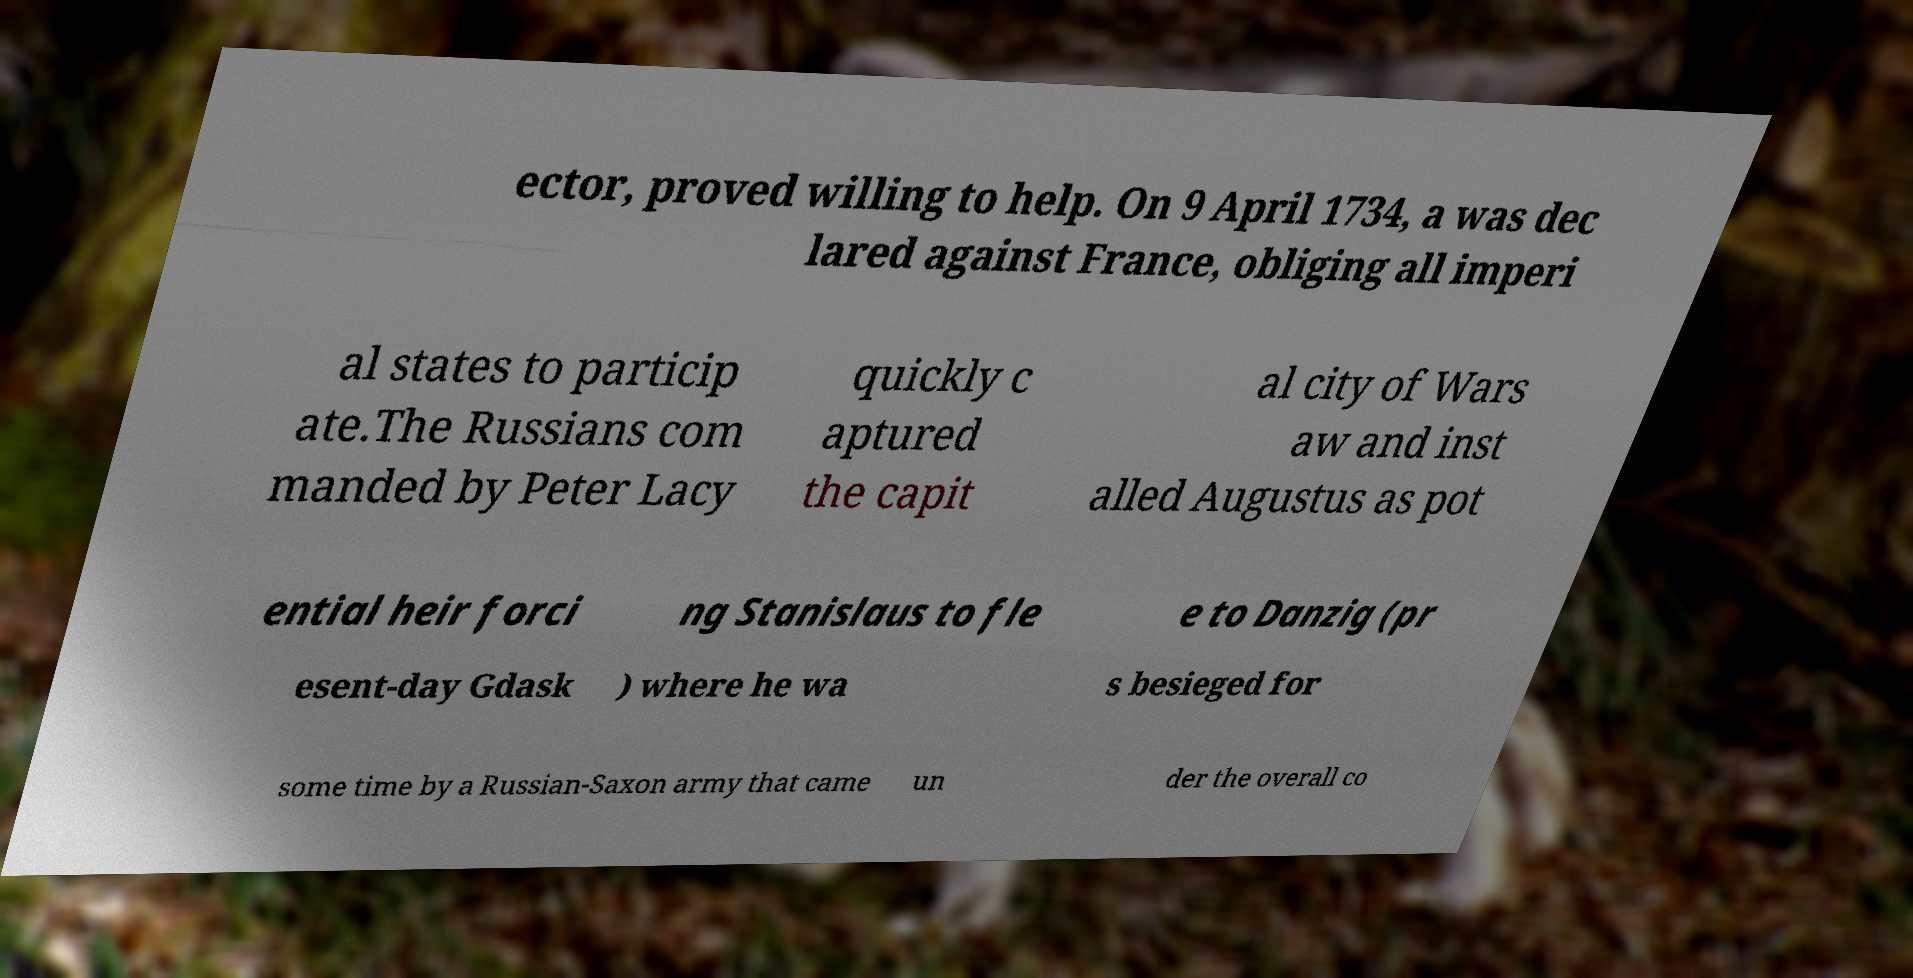Please read and relay the text visible in this image. What does it say? ector, proved willing to help. On 9 April 1734, a was dec lared against France, obliging all imperi al states to particip ate.The Russians com manded by Peter Lacy quickly c aptured the capit al city of Wars aw and inst alled Augustus as pot ential heir forci ng Stanislaus to fle e to Danzig (pr esent-day Gdask ) where he wa s besieged for some time by a Russian-Saxon army that came un der the overall co 